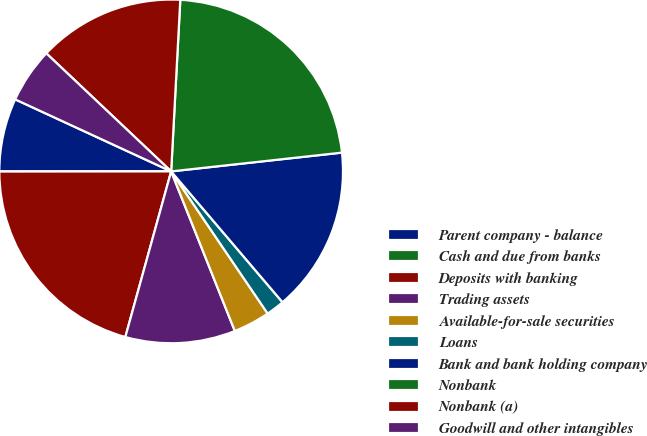Convert chart to OTSL. <chart><loc_0><loc_0><loc_500><loc_500><pie_chart><fcel>Parent company - balance<fcel>Cash and due from banks<fcel>Deposits with banking<fcel>Trading assets<fcel>Available-for-sale securities<fcel>Loans<fcel>Bank and bank holding company<fcel>Nonbank<fcel>Nonbank (a)<fcel>Goodwill and other intangibles<nl><fcel>6.9%<fcel>0.0%<fcel>20.69%<fcel>10.34%<fcel>3.45%<fcel>1.73%<fcel>15.52%<fcel>22.41%<fcel>13.79%<fcel>5.17%<nl></chart> 